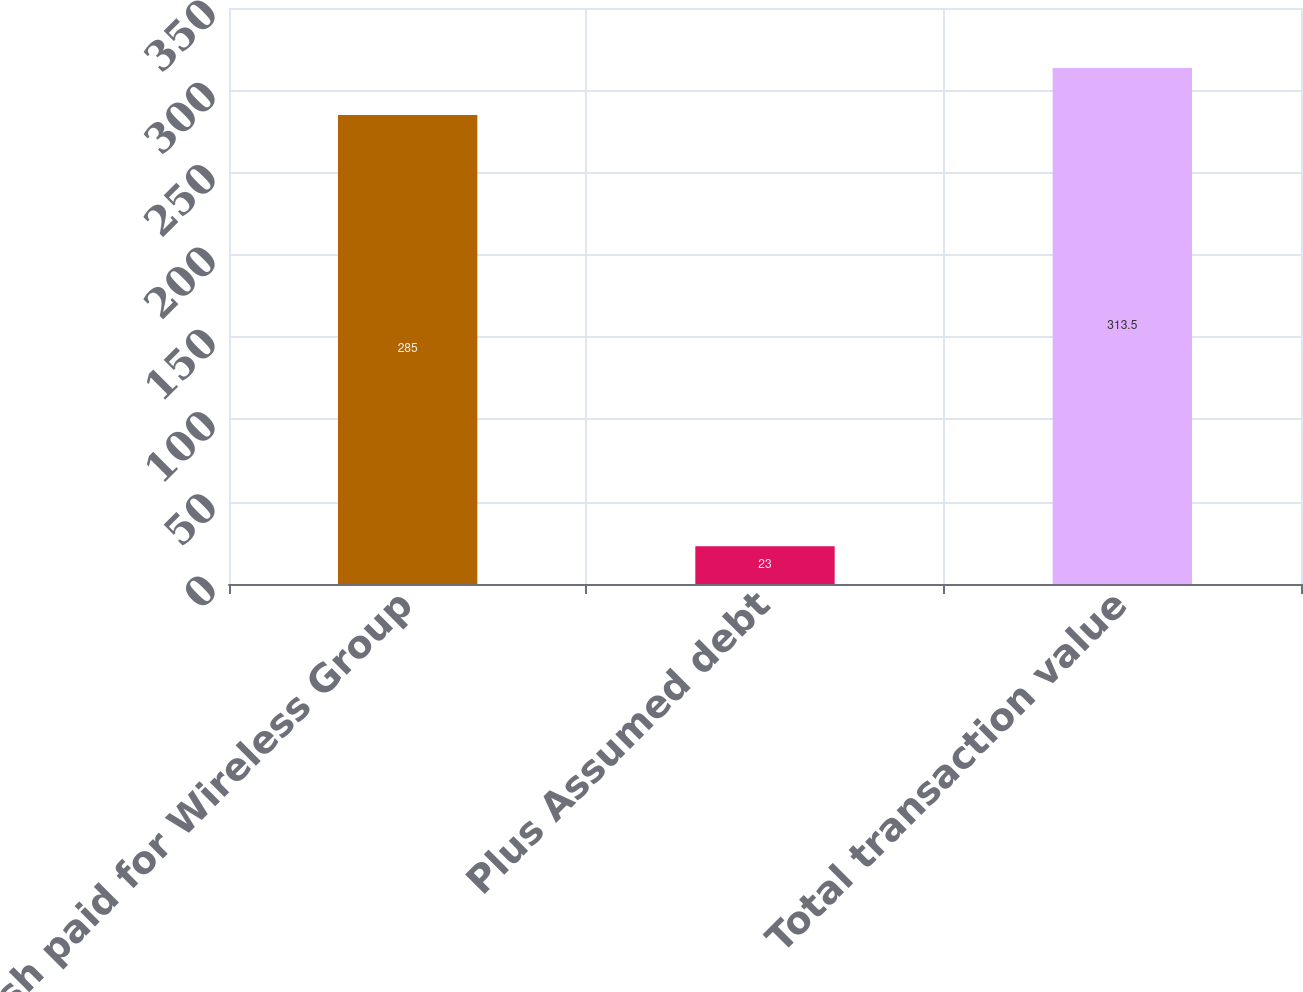<chart> <loc_0><loc_0><loc_500><loc_500><bar_chart><fcel>Cash paid for Wireless Group<fcel>Plus Assumed debt<fcel>Total transaction value<nl><fcel>285<fcel>23<fcel>313.5<nl></chart> 